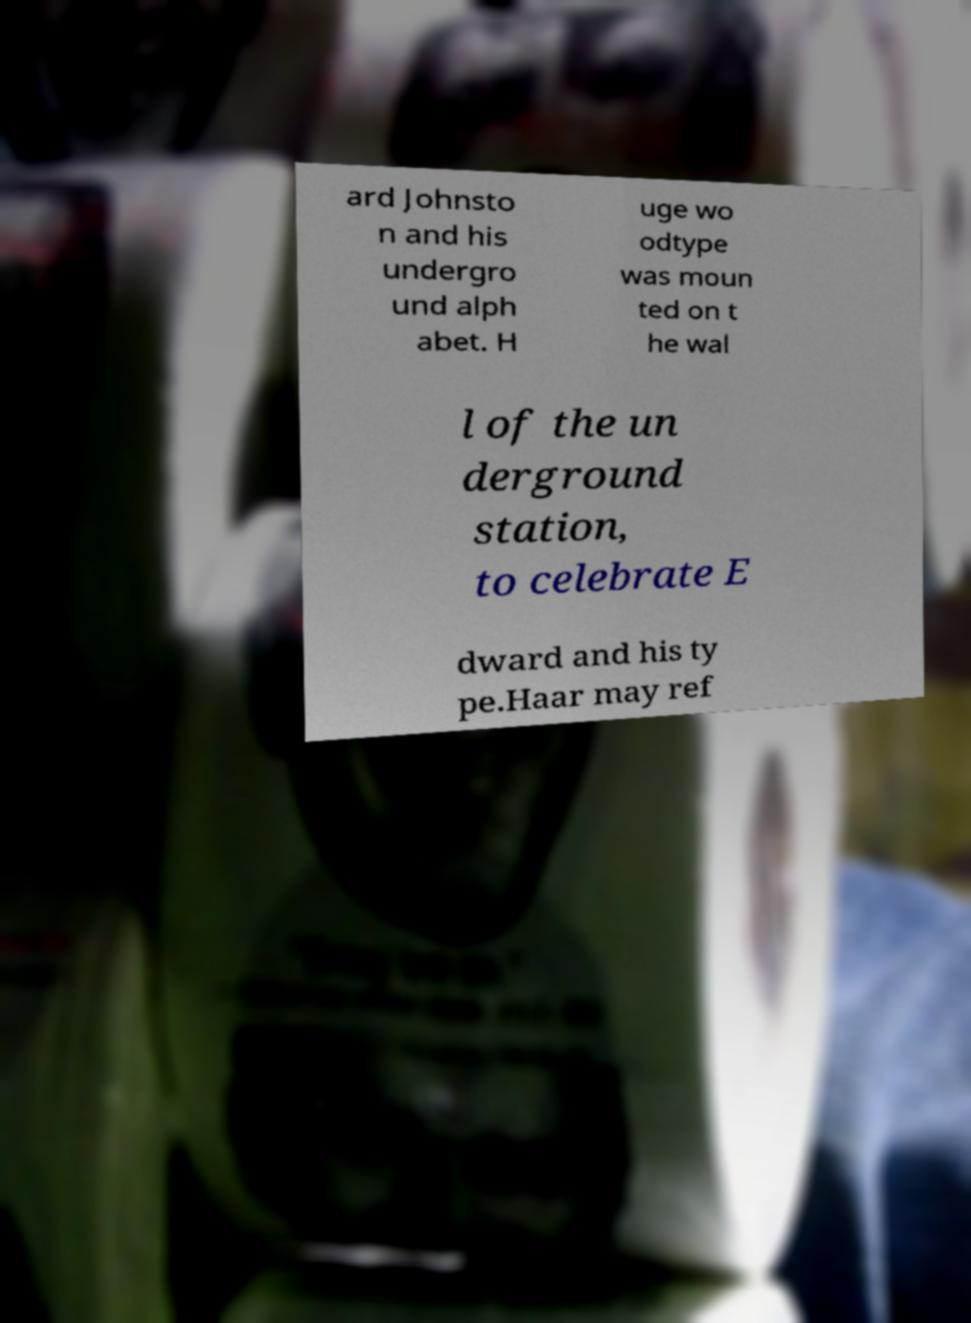I need the written content from this picture converted into text. Can you do that? ard Johnsto n and his undergro und alph abet. H uge wo odtype was moun ted on t he wal l of the un derground station, to celebrate E dward and his ty pe.Haar may ref 